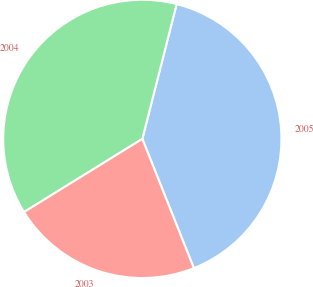Convert chart to OTSL. <chart><loc_0><loc_0><loc_500><loc_500><pie_chart><fcel>2005<fcel>2004<fcel>2003<nl><fcel>40.0%<fcel>37.78%<fcel>22.22%<nl></chart> 